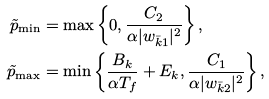<formula> <loc_0><loc_0><loc_500><loc_500>\tilde { p } _ { \min } & = \max \left \{ 0 , \frac { C _ { 2 } } { \alpha | w _ { \bar { k } 1 } | ^ { 2 } } \right \} , \\ \tilde { p } _ { \max } & = \min \left \{ \frac { B _ { k } } { \alpha T _ { f } } + E _ { k } , \frac { C _ { 1 } } { \alpha | w _ { \bar { k } 2 } | ^ { 2 } } \right \} ,</formula> 